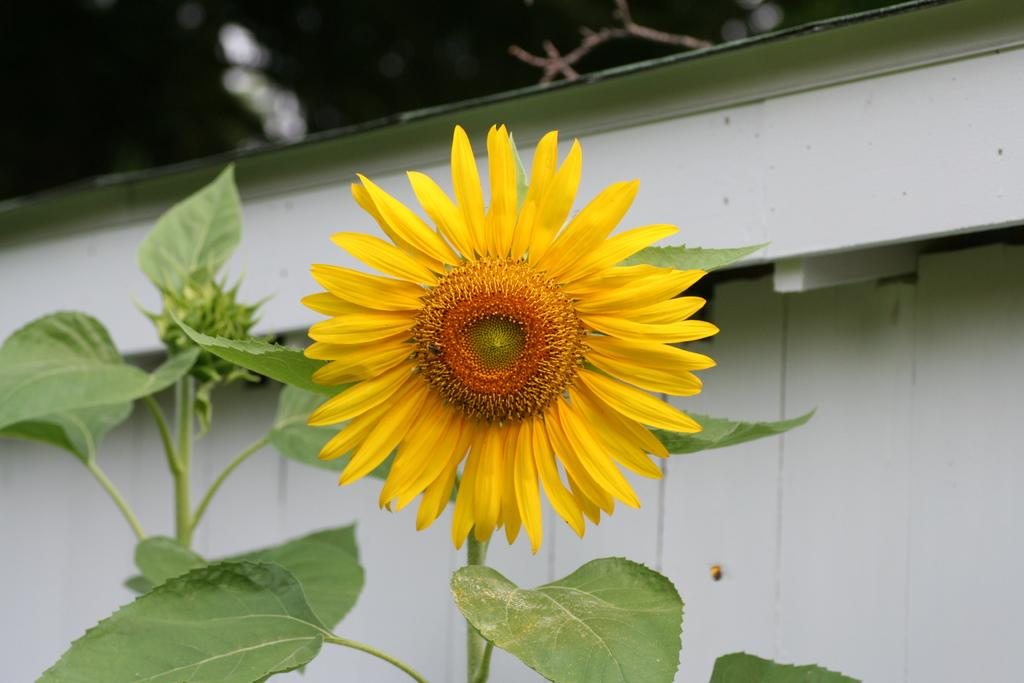What type of living organisms can be seen in the image? Plants and a flower are visible in the image. Can you describe the flower in the image? There is a flower in the image, but its specific characteristics are not mentioned in the facts. What can be seen in the background of the image? There appears to be a house in the background of the image. What type of mist can be seen surrounding the plants in the image? There is no mention of mist in the image; the plants are not surrounded by any mist. 